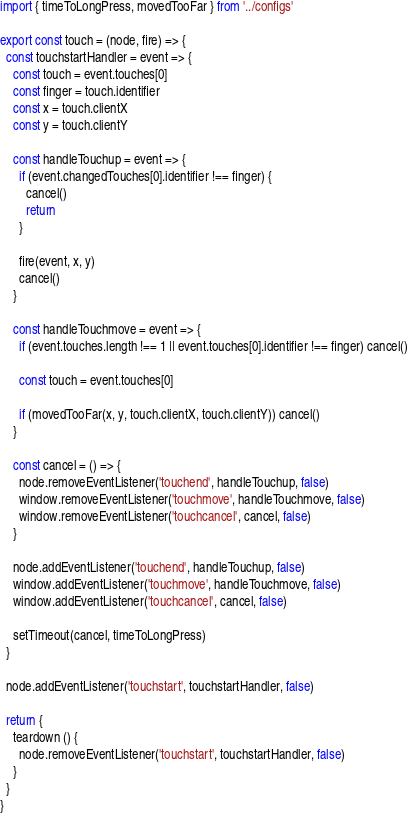<code> <loc_0><loc_0><loc_500><loc_500><_JavaScript_>import { timeToLongPress, movedTooFar } from '../configs'

export const touch = (node, fire) => {
  const touchstartHandler = event => {
    const touch = event.touches[0]
    const finger = touch.identifier
    const x = touch.clientX
    const y = touch.clientY

    const handleTouchup = event => {
      if (event.changedTouches[0].identifier !== finger) {
        cancel()
        return
      }

      fire(event, x, y)
      cancel()
    }

    const handleTouchmove = event => {
      if (event.touches.length !== 1 || event.touches[0].identifier !== finger) cancel()

      const touch = event.touches[0]

      if (movedTooFar(x, y, touch.clientX, touch.clientY)) cancel()
    }

    const cancel = () => {
      node.removeEventListener('touchend', handleTouchup, false)
      window.removeEventListener('touchmove', handleTouchmove, false)
      window.removeEventListener('touchcancel', cancel, false)
    }

    node.addEventListener('touchend', handleTouchup, false)
    window.addEventListener('touchmove', handleTouchmove, false)
    window.addEventListener('touchcancel', cancel, false)

    setTimeout(cancel, timeToLongPress)
  }

  node.addEventListener('touchstart', touchstartHandler, false)

  return {
    teardown () {
      node.removeEventListener('touchstart', touchstartHandler, false)
    }
  }
}
</code> 